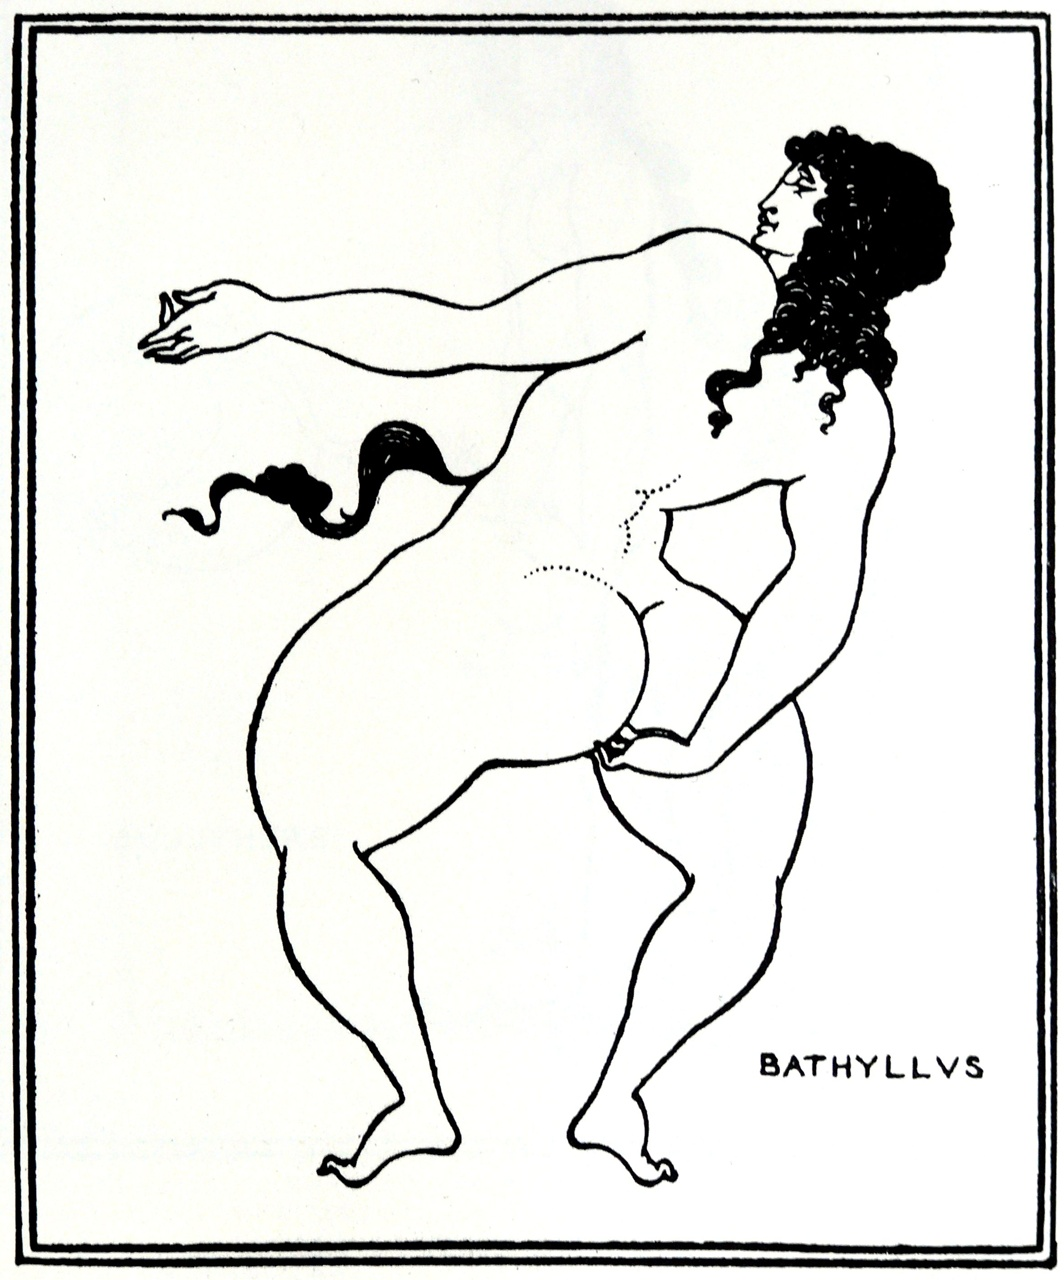Assuming this figure is from a mythical tale, what story could they belong to? The figure named 'BATHYLLVS' might belong to an ancient Greek myth, perhaps a lesser-known tale of a young man who captured the attention of the gods with his extraordinary talents and beauty. Bathyllus could be an artisan favored by the goddess Athena, patroness of wisdom and crafts. Once, during a grand festival devoted to her, he presented a finely crafted object of golden laurel, a symbol of peace and victory. In reward, Athena blessed him with a vision of heroism that led him to become a legendary figure, revered not only for his art but for his embodiment of the ideals of strength, beauty, and intellect. His dynamic pose in the image may signify the moment of divine inspiration or a pivotal event in his life. 